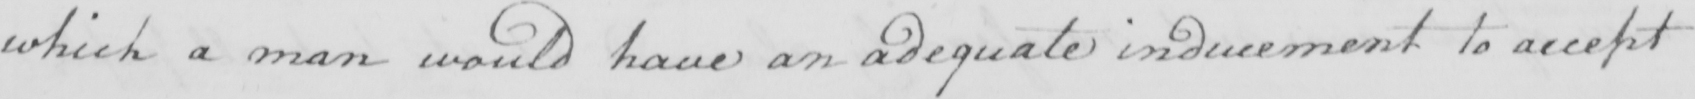Can you tell me what this handwritten text says? which a man would have an adequate inducement to accept 